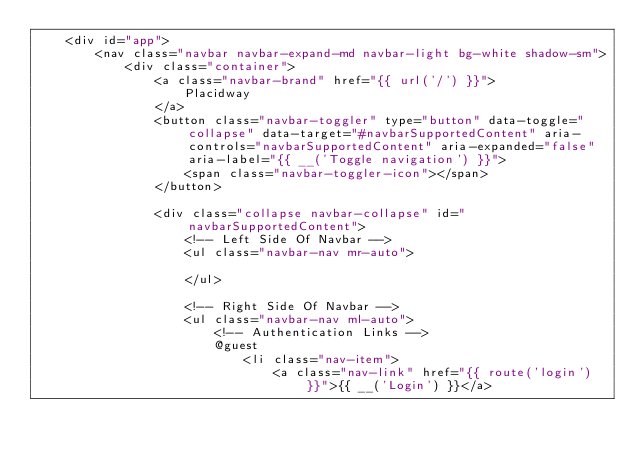<code> <loc_0><loc_0><loc_500><loc_500><_PHP_>    <div id="app">
        <nav class="navbar navbar-expand-md navbar-light bg-white shadow-sm">
            <div class="container">
                <a class="navbar-brand" href="{{ url('/') }}">
                    Placidway
                </a>
                <button class="navbar-toggler" type="button" data-toggle="collapse" data-target="#navbarSupportedContent" aria-controls="navbarSupportedContent" aria-expanded="false" aria-label="{{ __('Toggle navigation') }}">
                    <span class="navbar-toggler-icon"></span>
                </button>

                <div class="collapse navbar-collapse" id="navbarSupportedContent">
                    <!-- Left Side Of Navbar -->
                    <ul class="navbar-nav mr-auto">

                    </ul>

                    <!-- Right Side Of Navbar -->
                    <ul class="navbar-nav ml-auto">
                        <!-- Authentication Links -->
                        @guest
                            <li class="nav-item">
                                <a class="nav-link" href="{{ route('login') }}">{{ __('Login') }}</a></code> 